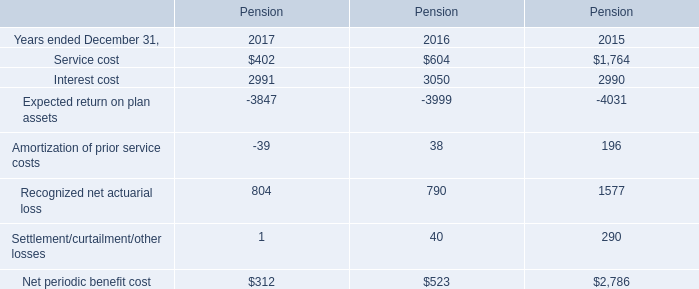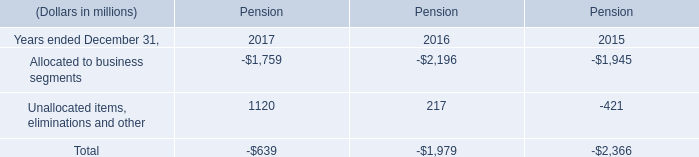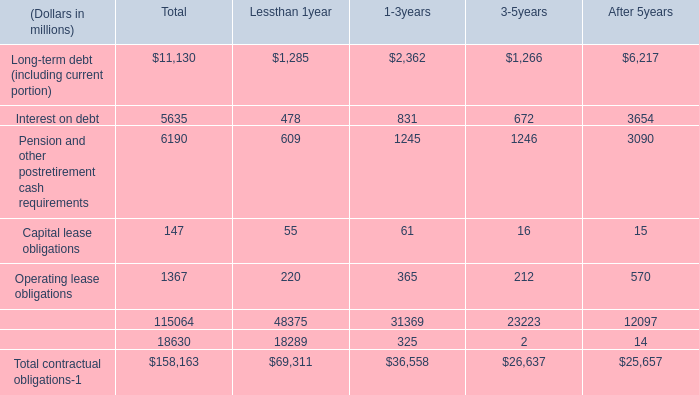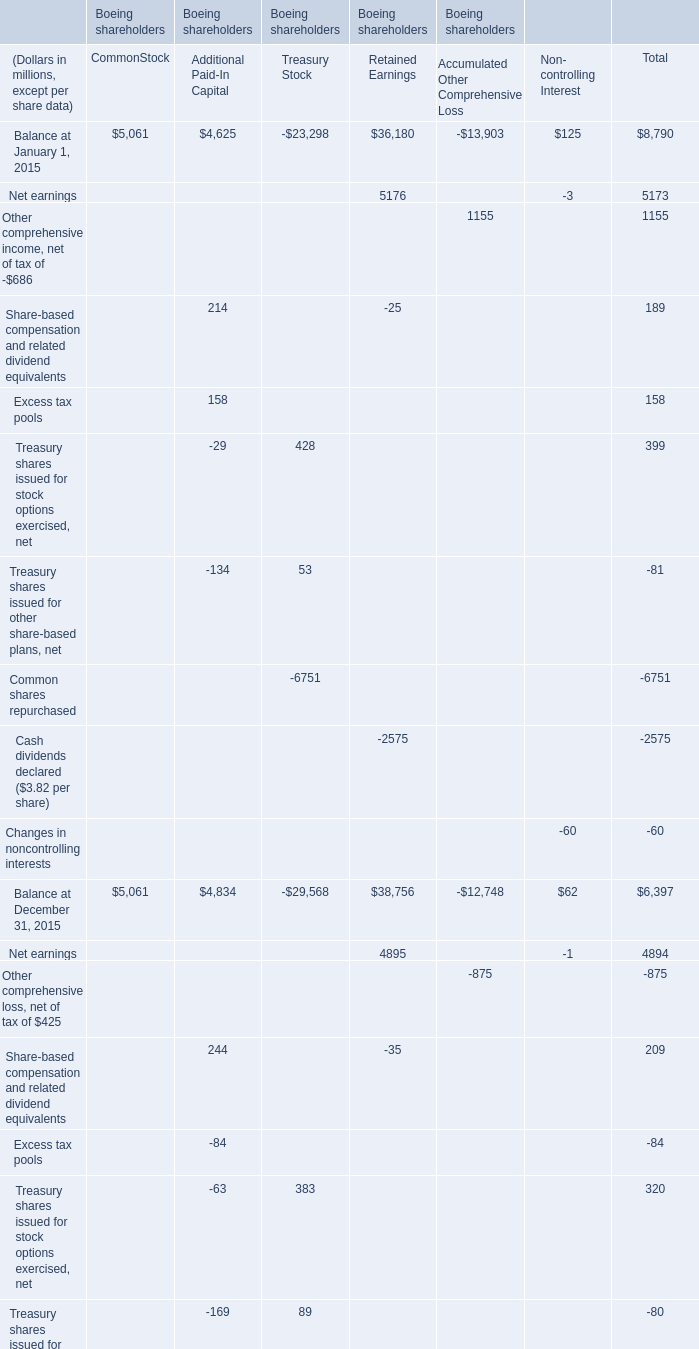What's the average of Balance at January 1, 2015? (in Dollars in millions, except per share data) 
Computations: (8790 / 6)
Answer: 1465.0. 